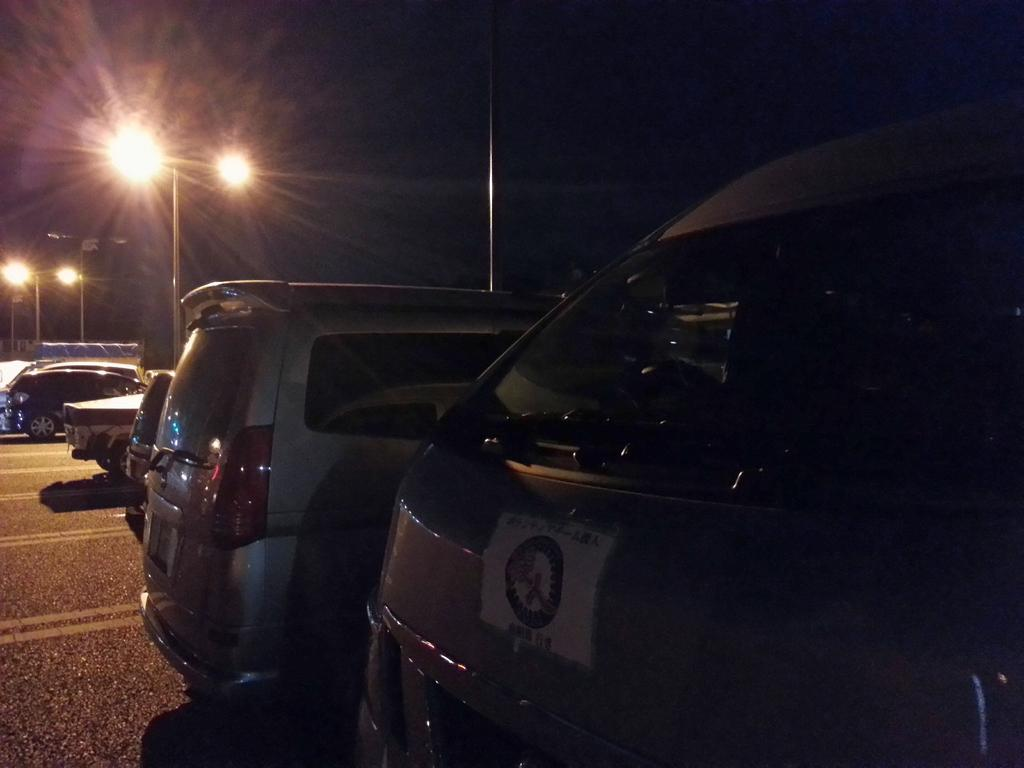What type of vehicles can be seen in the image? There are cars in the image. What else is present in the image besides the cars? There are lights in the image. How would you describe the overall lighting in the image? The image appears to be dark. How many loaves of bread are being supported by the cars in the image? There are: There are no loaves of bread present in the image, and the cars are not supporting any. 